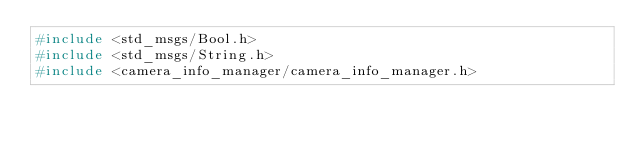Convert code to text. <code><loc_0><loc_0><loc_500><loc_500><_C_>#include <std_msgs/Bool.h>
#include <std_msgs/String.h>
#include <camera_info_manager/camera_info_manager.h></code> 